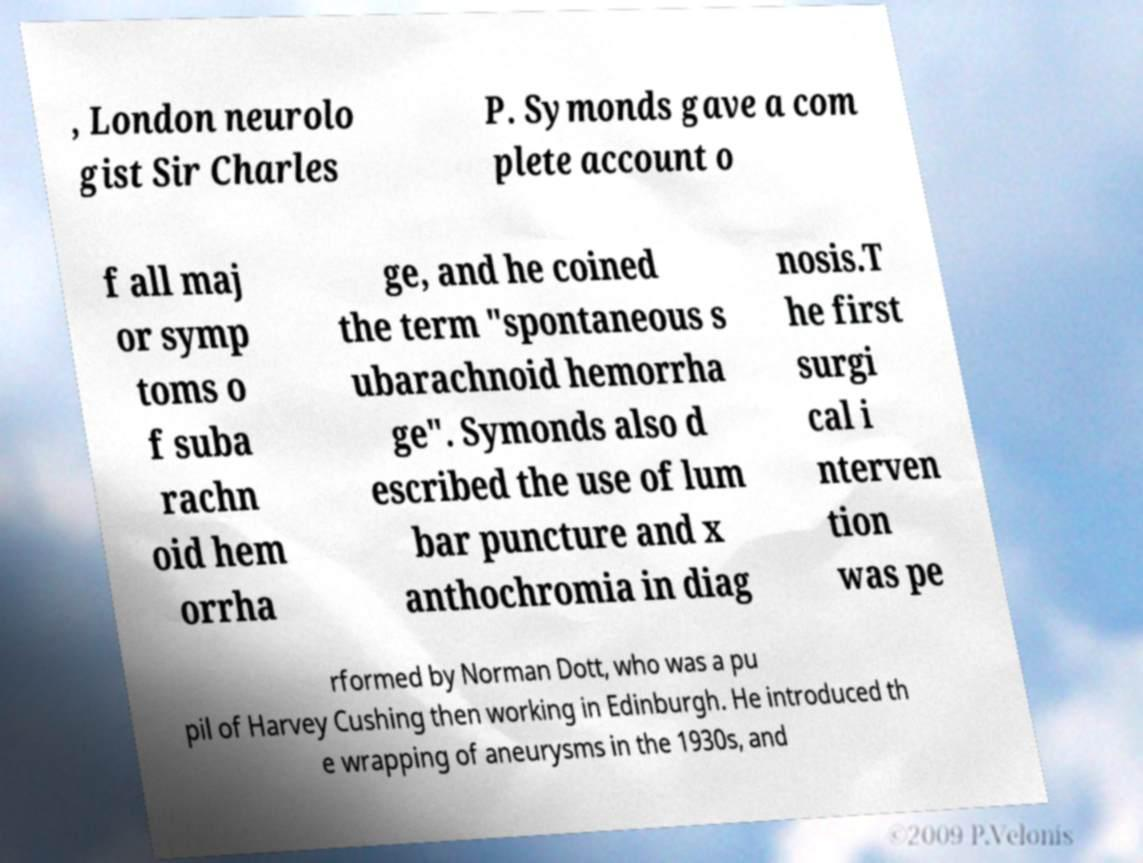Could you assist in decoding the text presented in this image and type it out clearly? , London neurolo gist Sir Charles P. Symonds gave a com plete account o f all maj or symp toms o f suba rachn oid hem orrha ge, and he coined the term "spontaneous s ubarachnoid hemorrha ge". Symonds also d escribed the use of lum bar puncture and x anthochromia in diag nosis.T he first surgi cal i nterven tion was pe rformed by Norman Dott, who was a pu pil of Harvey Cushing then working in Edinburgh. He introduced th e wrapping of aneurysms in the 1930s, and 